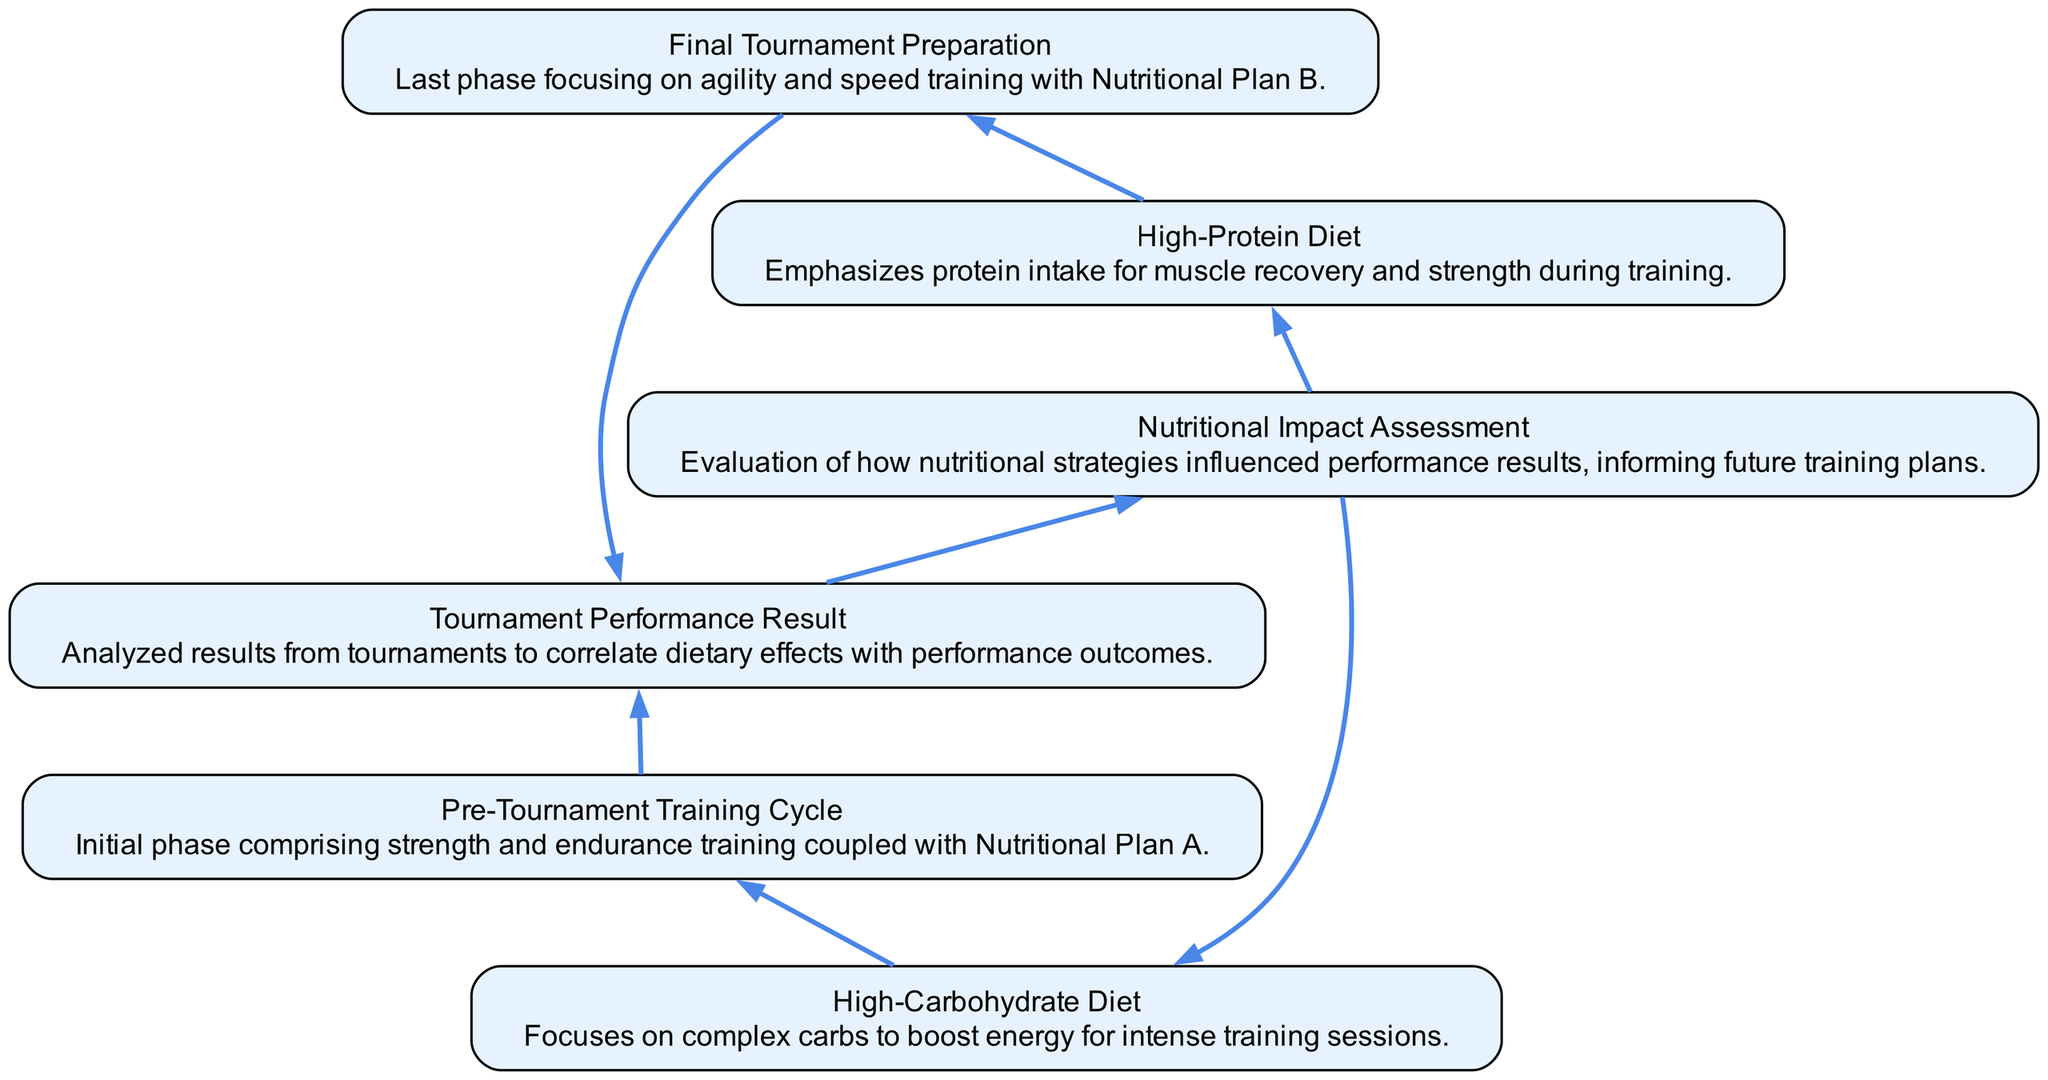What is the name of the first nutritional plan? The first node listed in the bottom of the flow chart is "Nutritional Plan A," which is a high-carbohydrate diet.
Answer: High-Carbohydrate Diet What is the purpose of the Feedback Loop? The Feedback Loop connects the results of tournament performance back to the nutritional plans, indicating that an assessment of nutritional impact informs future training strategies.
Answer: Nutritional Impact Assessment How many training cycles are represented in the diagram? There are two nodes labeled as training cycles in the diagram: "Pre-Tournament Training Cycle" and "Final Tournament Preparation."
Answer: 2 Which nutritional plan is used in the Pre-Tournament Training Cycle? Tracing from the "Pre-Tournament Training Cycle" node back to the nutritional plan shows it is associated with "Nutritional Plan A."
Answer: High-Carbohydrate Diet What do the arrows in the diagram represent? The arrows indicate the flow of influence or connection between different components, showing how different elements relate to each other, such as nutritional planning affecting training cycles and results.
Answer: Relationships How does the Final Tournament Preparation relate to nutritional plans? The diagram indicates that "Final Tournament Preparation" is connected to "Nutritional Plan B," showing its influence for the last phase before a tournament.
Answer: High-Protein Diet What is the result identified in the diagram? The node labeled "Result A" summarizes the outcome analyzed from tournaments, correlating both nutritional plans with performance.
Answer: Tournament Performance Result Which nutritional plan is influenced by the Feedback Loop? The Feedback Loop connects back to both nutritional plans A and B, suggesting that both are subject to evaluation based on performance assessment.
Answer: Nutritional Plan A and Nutritional Plan B What type of dietary focus does Nutritional Plan B emphasize? The description of "Nutritional Plan B" states that it emphasizes protein intake for muscle recovery, pointing to a strong emphasis on strength.
Answer: Protein intake 